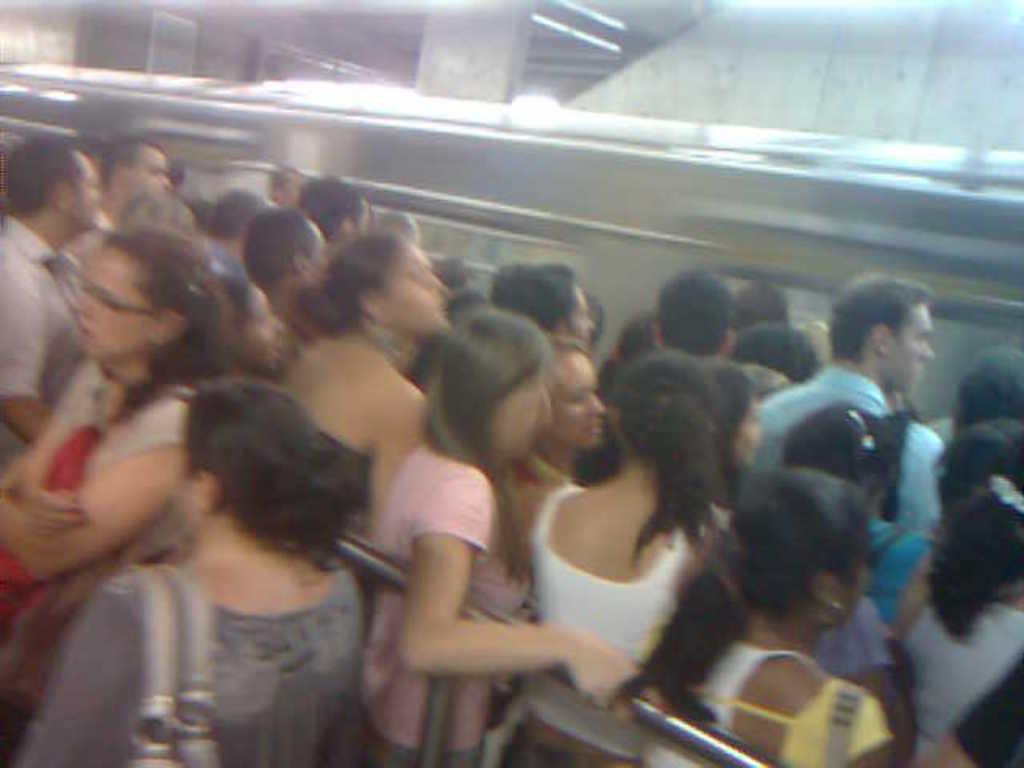How would you summarize this image in a sentence or two? In this image we can see so many people are standing, one train, one board attached to the wall, two pillars, some people are holding objects and one woman is holding the pole. 